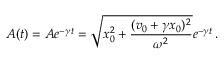Convert formula to latex. <formula><loc_0><loc_0><loc_500><loc_500>A ( t ) = A e ^ { - \gamma t } = \sqrt { x _ { 0 } ^ { 2 } + \frac { ( v _ { 0 } + \gamma x _ { 0 } ) ^ { 2 } } { \omega ^ { 2 } } } e ^ { - \gamma t } \, .</formula> 